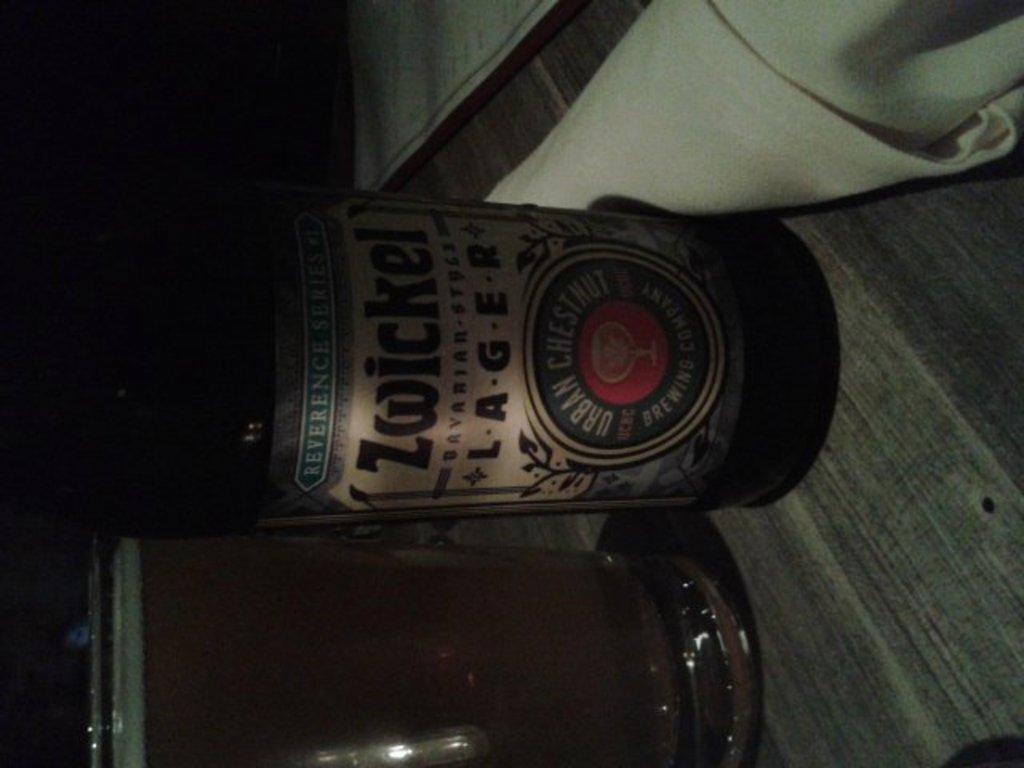What brand of alcohol is this?
Give a very brief answer. Zwickel. What type of beer is labeled?
Keep it short and to the point. Zwickel. 